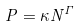<formula> <loc_0><loc_0><loc_500><loc_500>P = \kappa N ^ { \Gamma }</formula> 